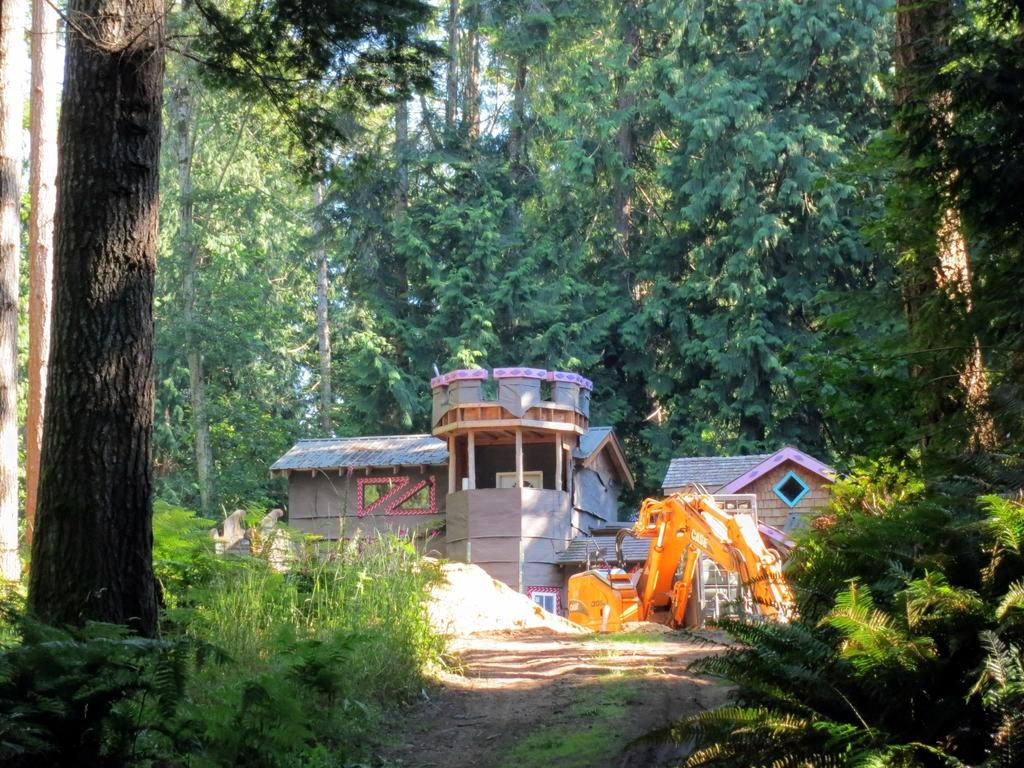What type of vegetation is present at the bottom of the image? There are plants on the ground at the bottom of the image. What other types of vegetation can be seen in the image? There are trees in the image. What type of structure is visible in the image? There is a house in the image. What other object can be seen in the image? There is a crane in the image. Can you see any icicles hanging from the trees in the image? There are no icicles present in the image; it appears to be a warm setting with trees and plants. Is there a group of people gathered around the crane in the image? There is no group of people visible in the image; only the crane and other objects are present. 